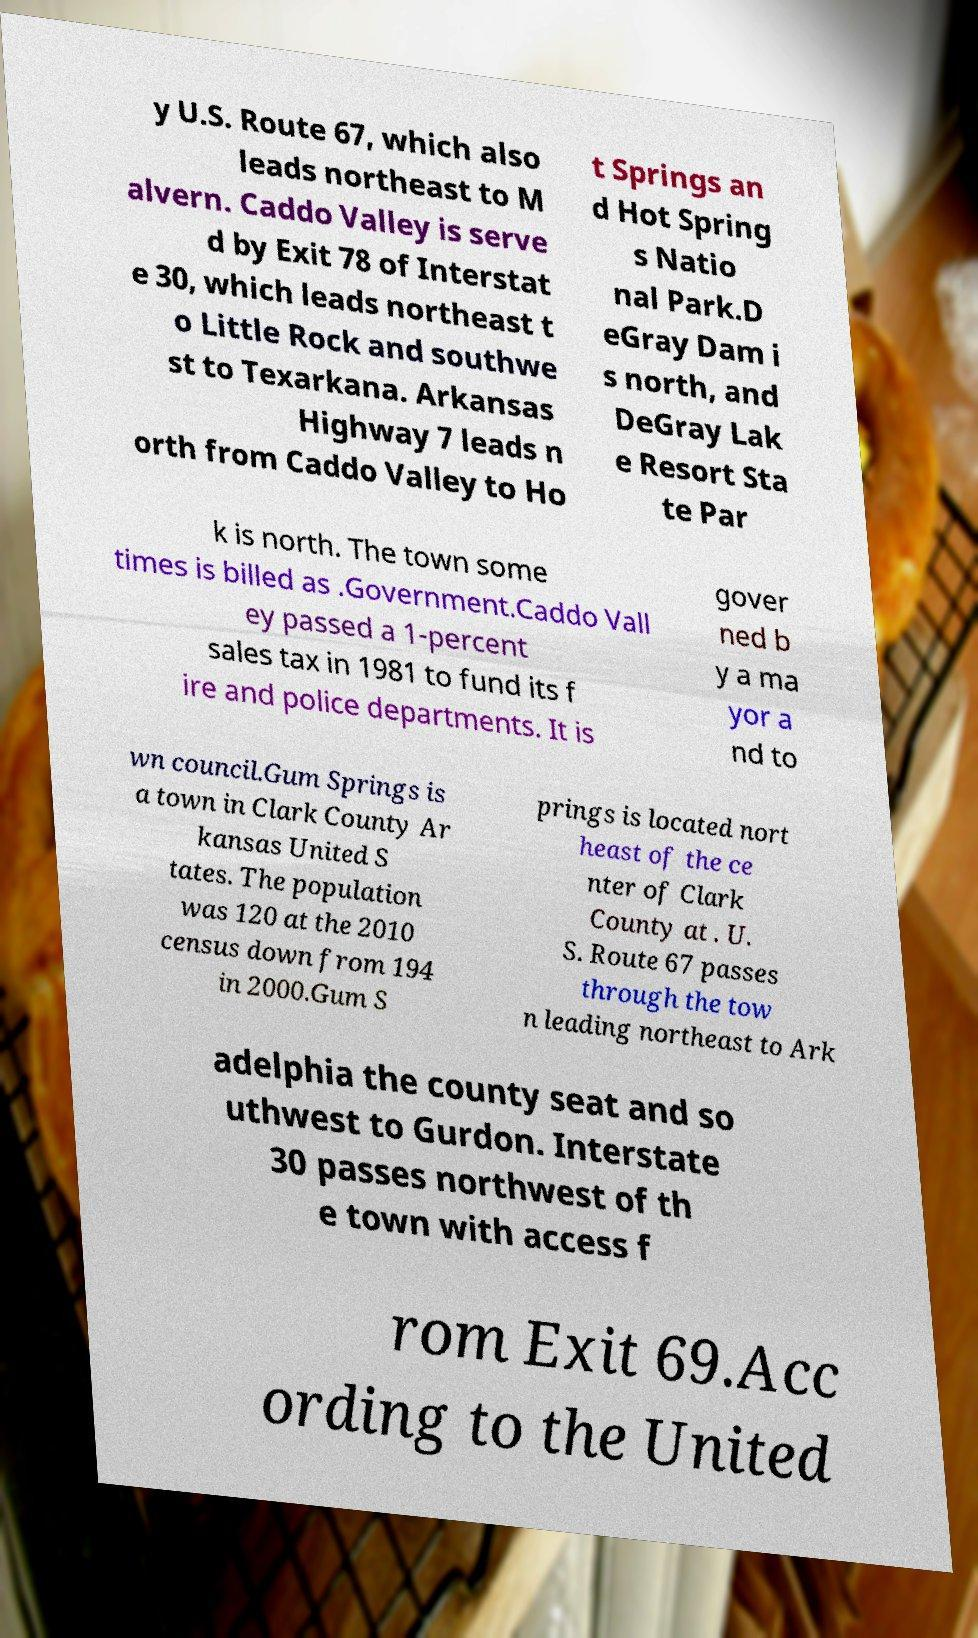There's text embedded in this image that I need extracted. Can you transcribe it verbatim? y U.S. Route 67, which also leads northeast to M alvern. Caddo Valley is serve d by Exit 78 of Interstat e 30, which leads northeast t o Little Rock and southwe st to Texarkana. Arkansas Highway 7 leads n orth from Caddo Valley to Ho t Springs an d Hot Spring s Natio nal Park.D eGray Dam i s north, and DeGray Lak e Resort Sta te Par k is north. The town some times is billed as .Government.Caddo Vall ey passed a 1-percent sales tax in 1981 to fund its f ire and police departments. It is gover ned b y a ma yor a nd to wn council.Gum Springs is a town in Clark County Ar kansas United S tates. The population was 120 at the 2010 census down from 194 in 2000.Gum S prings is located nort heast of the ce nter of Clark County at . U. S. Route 67 passes through the tow n leading northeast to Ark adelphia the county seat and so uthwest to Gurdon. Interstate 30 passes northwest of th e town with access f rom Exit 69.Acc ording to the United 